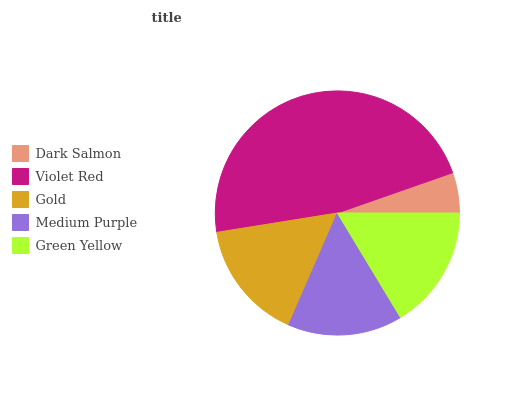Is Dark Salmon the minimum?
Answer yes or no. Yes. Is Violet Red the maximum?
Answer yes or no. Yes. Is Gold the minimum?
Answer yes or no. No. Is Gold the maximum?
Answer yes or no. No. Is Violet Red greater than Gold?
Answer yes or no. Yes. Is Gold less than Violet Red?
Answer yes or no. Yes. Is Gold greater than Violet Red?
Answer yes or no. No. Is Violet Red less than Gold?
Answer yes or no. No. Is Gold the high median?
Answer yes or no. Yes. Is Gold the low median?
Answer yes or no. Yes. Is Medium Purple the high median?
Answer yes or no. No. Is Medium Purple the low median?
Answer yes or no. No. 